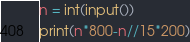Convert code to text. <code><loc_0><loc_0><loc_500><loc_500><_Python_>n = int(input())
print(n*800-n//15*200)</code> 